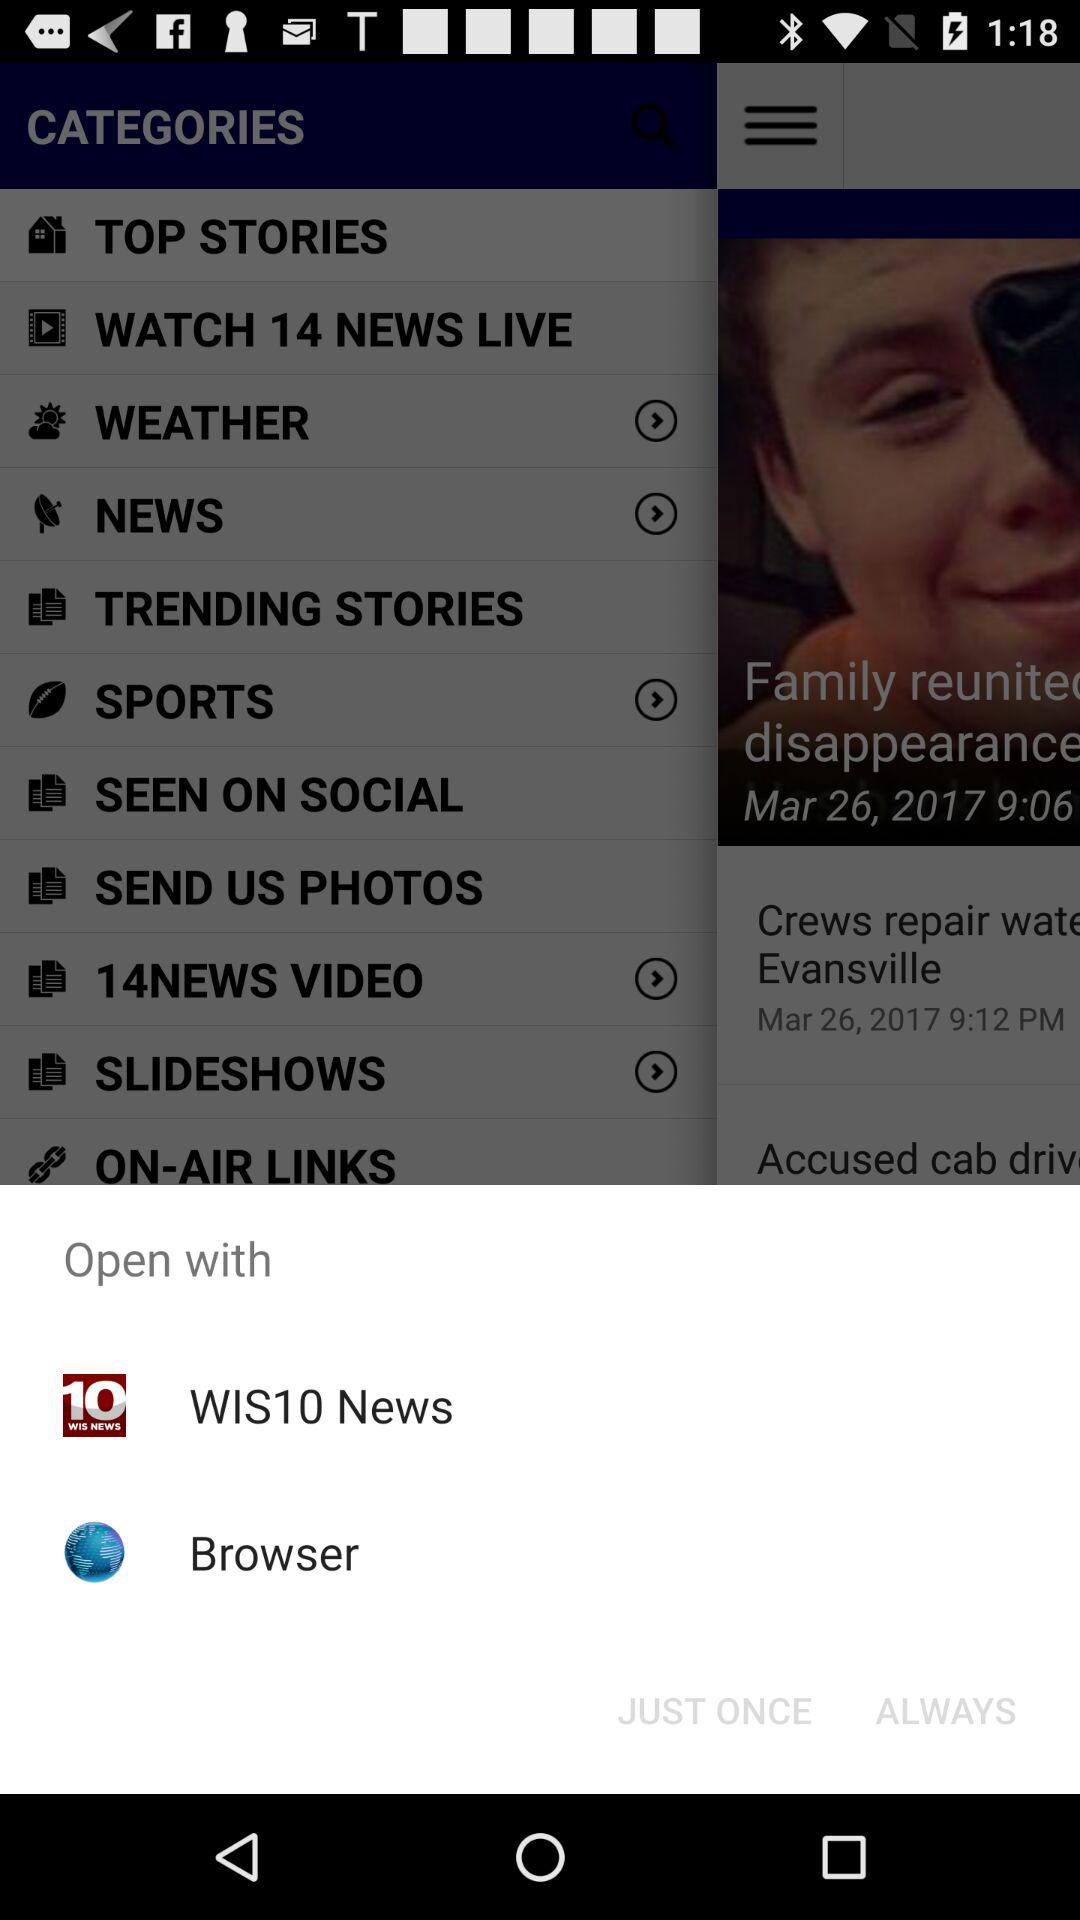Through what applications can we open with? You can open with "WIS10 News" and "Browser". 